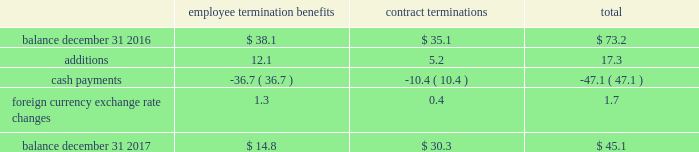Zimmer biomet holdings , inc .
And subsidiaries 2017 form 10-k annual report notes to consolidated financial statements ( continued ) substantially complete .
The table summarizes the liabilities related to these integration plans ( in millions ) : employee termination benefits contract terminations total .
We have also recognized other employee termination benefits related to ldr , other acquisitions and our operational excellence initiatives .
Dedicated project personnel expenses include the salary , benefits , travel expenses and other costs directly associated with employees who are 100 percent dedicated to our integration of acquired businesses , employees who have been notified of termination , but are continuing to work on transferring their responsibilities and employees working on our quality enhancement and remediation efforts and operational excellence initiatives .
Relocated facilities expenses are the moving costs , lease expenses and other facility costs incurred during the relocation period in connection with relocating certain facilities .
Certain litigation matters relate to net expenses recognized during the year for the estimated or actual settlement of certain pending litigation and similar claims , including matters where we recognized income from a settlement on more favorable terms than our previous estimate , or we reduced our estimate of a previously recorded contingent liability .
These litigation matters have included royalty disputes , patent litigation matters , product liability litigation matters and commercial litigation matters .
Contract termination costs relate to terminated agreements in connection with the integration of acquired companies and changes to our distribution model as part of business restructuring and operational excellence initiatives .
The terminated contracts primarily relate to sales agents and distribution agreements .
Information technology integration costs are non- capitalizable costs incurred related to integrating information technology platforms of acquired companies or other significant software implementations as part of our quality and operational excellence initiatives .
As part of the biomet merger , we recognized $ 209.0 million of intangible assets for in-process research and development ( 201cipr&d 201d ) projects .
During 2017 and 2016 , we recorded impairment losses of $ 18.8 million and $ 30.0 million , respectively , related to these ipr&d intangible assets .
The impairments were primarily due to the termination of certain ipr&d projects .
We also recognized $ 479.0 million of intangible assets for trademarks that we designated as having an indefinite life .
During 2017 , we reclassified one of these trademarks to a finite life asset which resulted in an impairment of $ 8.0 million .
Loss/impairment on disposal of assets relates to assets that we have sold or intend to sell , or for which the economic useful life of the asset has been significantly reduced due to integration or our quality and operational excellence initiatives .
Contingent consideration adjustments represent the changes in the fair value of contingent consideration obligations to be paid to the prior owners of acquired businesses .
Certain r&d agreements relate to agreements with upfront payments to obtain intellectual property to be used in r&d projects that have no alternative future use in other projects .
Cash and cash equivalents 2013 we consider all highly liquid investments with an original maturity of three months or less to be cash equivalents .
The carrying amounts reported in the balance sheet for cash and cash equivalents are valued at cost , which approximates their fair value .
Accounts receivable 2013 accounts receivable consists of trade and other miscellaneous receivables .
We grant credit to customers in the normal course of business and maintain an allowance for doubtful accounts for potential credit losses .
We determine the allowance for doubtful accounts by geographic market and take into consideration historical credit experience , creditworthiness of the customer and other pertinent information .
We make concerted efforts to collect all accounts receivable , but sometimes we have to write-off the account against the allowance when we determine the account is uncollectible .
The allowance for doubtful accounts was $ 60.2 million and $ 51.6 million as of december 31 , 2017 and 2016 , respectively .
Inventories 2013 inventories are stated at the lower of cost or market , with cost determined on a first-in first-out basis .
Property , plant and equipment 2013 property , plant and equipment is carried at cost less accumulated depreciation .
Depreciation is computed using the straight-line method based on estimated useful lives of ten to forty years for buildings and improvements and three to eight years for machinery and equipment .
Maintenance and repairs are expensed as incurred .
We review property , plant and equipment for impairment whenever events or changes in circumstances indicate that the carrying value of an asset may not be recoverable .
An impairment loss would be recognized when estimated future undiscounted cash flows relating to the asset are less than its carrying amount .
An impairment loss is measured as the amount by which the carrying amount of an asset exceeds its fair value .
Software costs 2013 we capitalize certain computer software and software development costs incurred in connection with developing or obtaining computer software for internal use when both the preliminary project stage is completed and it is probable that the software will be used as intended .
Capitalized software costs generally include external direct costs of materials and services utilized in developing or obtaining computer software and compensation and related .
What was the percentage change in the allowance for doubtful accounts between 2016 and 2017? 
Computations: ((60.2 - 51.6) / 51.6)
Answer: 0.16667. 